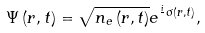<formula> <loc_0><loc_0><loc_500><loc_500>\Psi \left ( { { r } , t } \right ) = \sqrt { n _ { e } \left ( { { r } , t } \right ) } e ^ { \frac { i } { } \sigma \left ( { r } , t \right ) } ,</formula> 